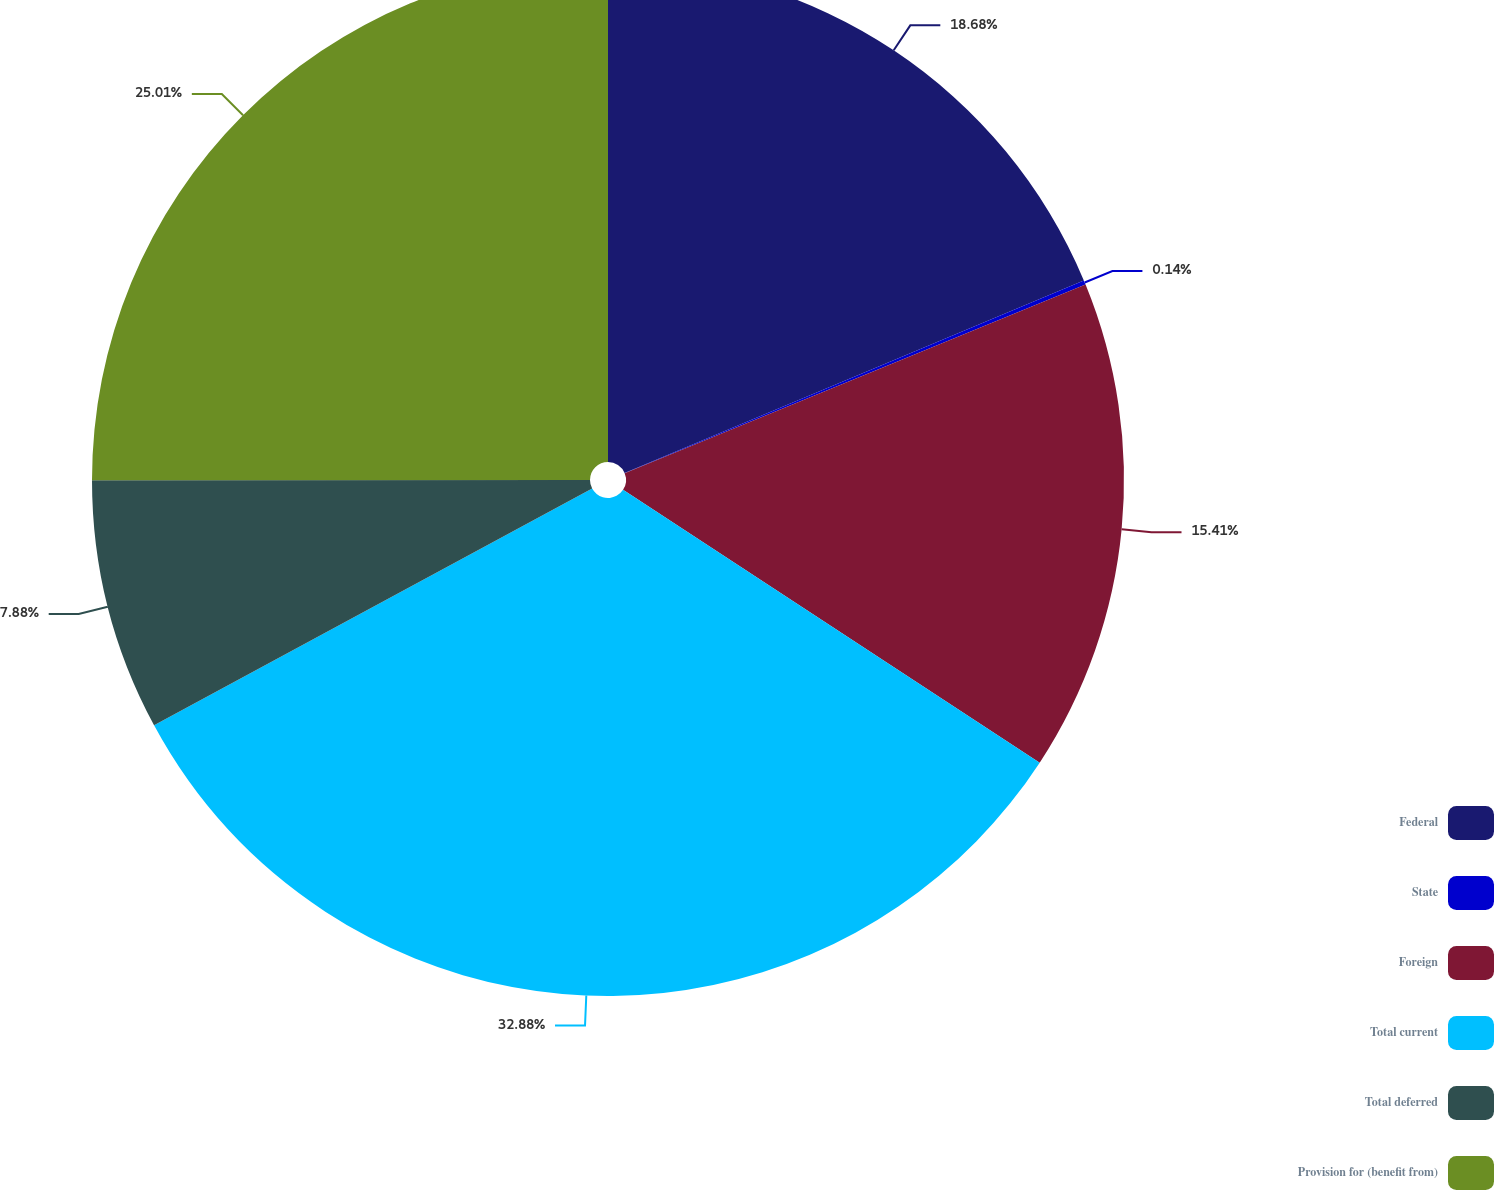<chart> <loc_0><loc_0><loc_500><loc_500><pie_chart><fcel>Federal<fcel>State<fcel>Foreign<fcel>Total current<fcel>Total deferred<fcel>Provision for (benefit from)<nl><fcel>18.68%<fcel>0.14%<fcel>15.41%<fcel>32.89%<fcel>7.88%<fcel>25.01%<nl></chart> 